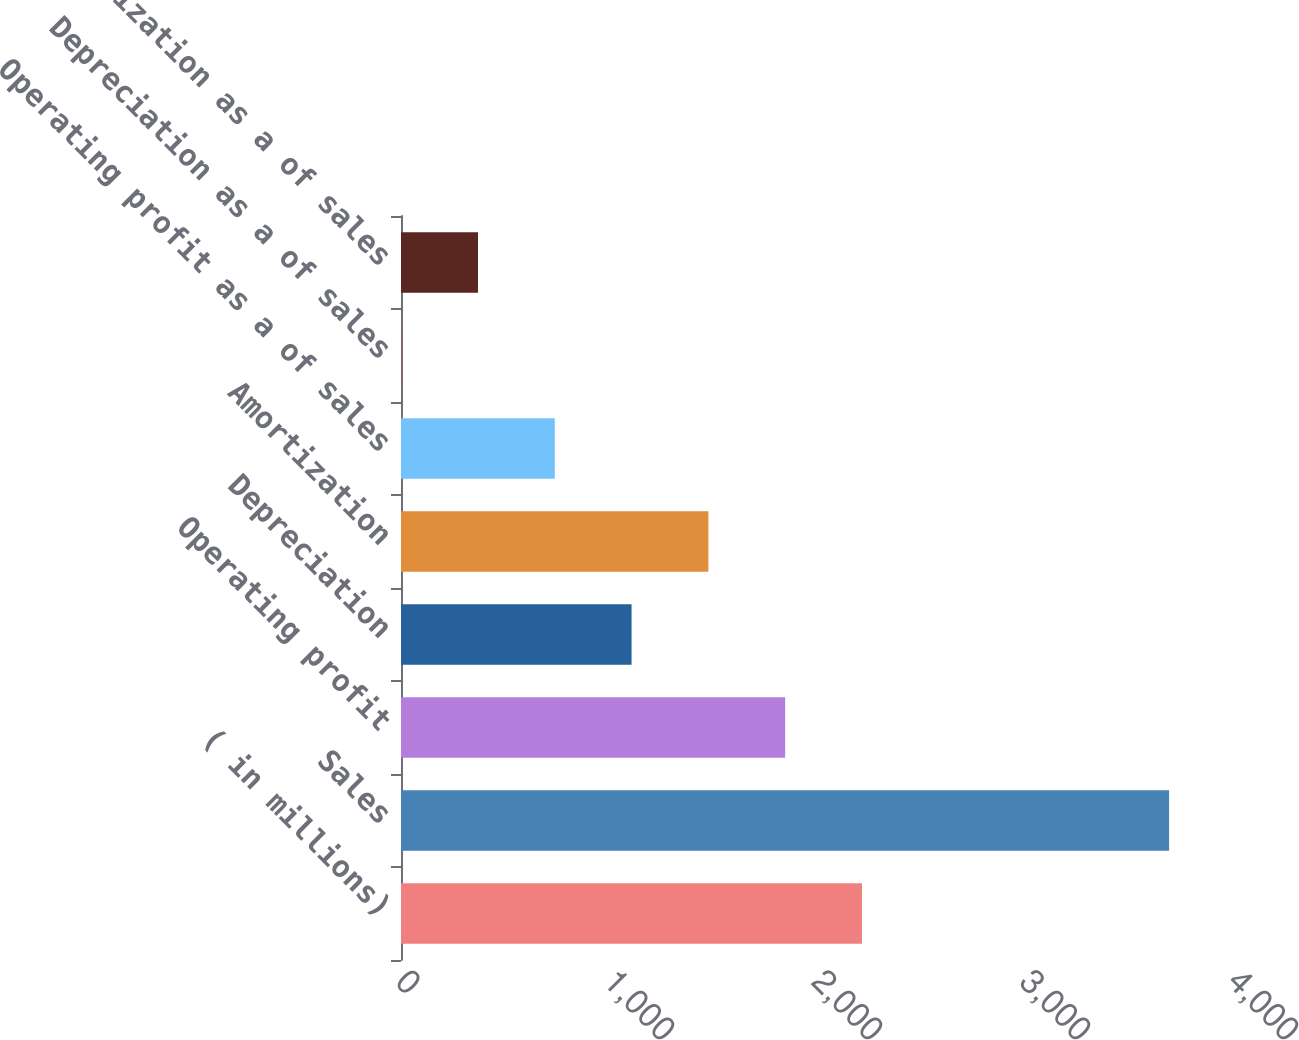<chart> <loc_0><loc_0><loc_500><loc_500><bar_chart><fcel>( in millions)<fcel>Sales<fcel>Operating profit<fcel>Depreciation<fcel>Amortization<fcel>Operating profit as a of sales<fcel>Depreciation as a of sales<fcel>Amortization as a of sales<nl><fcel>2216.08<fcel>3692.8<fcel>1846.9<fcel>1108.54<fcel>1477.72<fcel>739.36<fcel>1<fcel>370.18<nl></chart> 